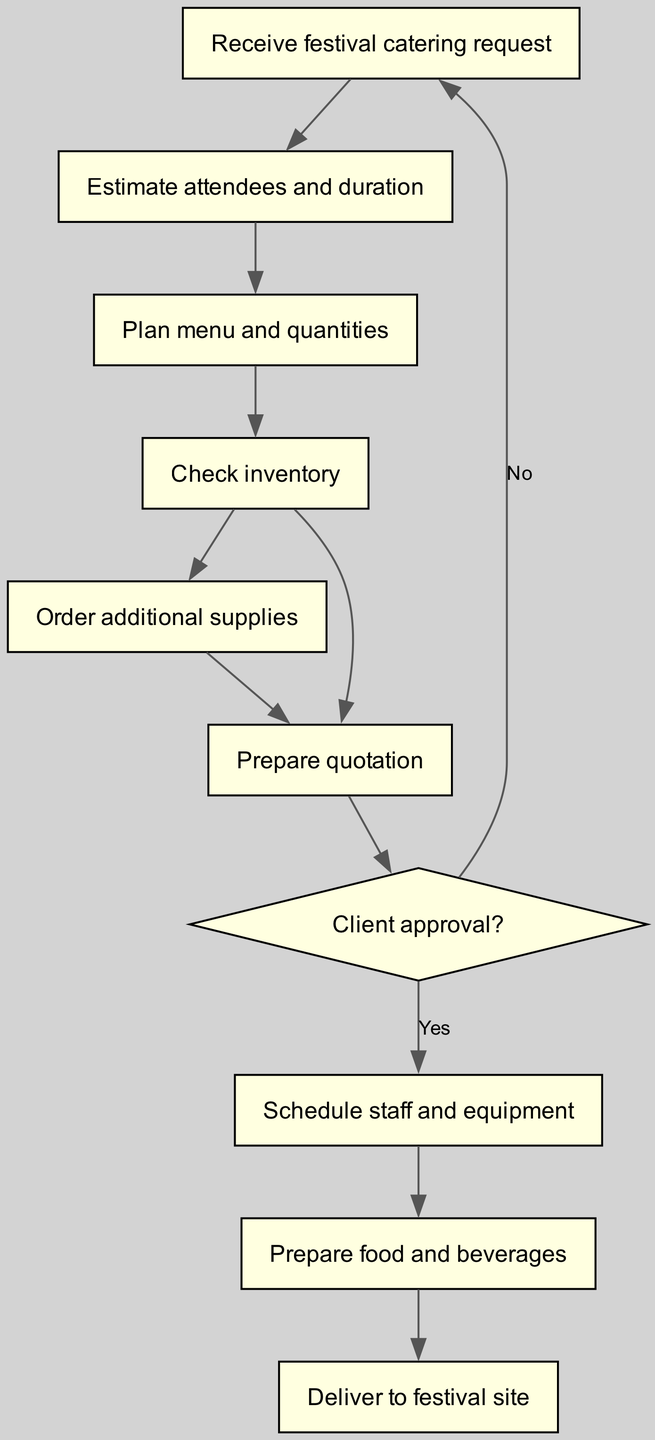What is the first step in the order processing workflow? The first step in the workflow is indicated by the starting node, which states "Receive festival catering request." Therefore, that is the first action to be taken after an event request is made.
Answer: Receive festival catering request How many total nodes are present in the diagram? To find the total nodes, we count all listed nodes in the data. There are a total of 10 nodes, each representing a specific step in the order processing workflow.
Answer: 10 What node follows "Plan menu and quantities"? Following "Plan menu and quantities," the next node is "Check inventory." This indicates the sequence of actions taken right after planning the menu.
Answer: Check inventory What is the decision node in the workflow? The decision node is a diamond-shaped node which asks, "Client approval?" It determines the next steps based on whether the client approves the quotation or not.
Answer: Client approval? If the client does not approve, what is the next action? If the client does not approve, the workflow points back to "Receive festival catering request," indicating that the process needs to start again to address the client’s feedback.
Answer: Receive festival catering request What is the final step in the order processing workflow? The final step in the workflow is "Deliver to festival site," which concludes the process by delivering the prepared food and beverages to the event location.
Answer: Deliver to festival site How many edges connect to "Prepare quotation"? The node "Prepare quotation" has two edges leading into it: one from "Order additional supplies" and one from "Check inventory." These represent the potential paths that could lead to preparing the quotation.
Answer: 2 Which node follows "Schedule staff and equipment"? The node that follows "Schedule staff and equipment" is "Prepare food and beverages." This shows the next action after organizing the staffing and equipment needed for the event.
Answer: Prepare food and beverages 